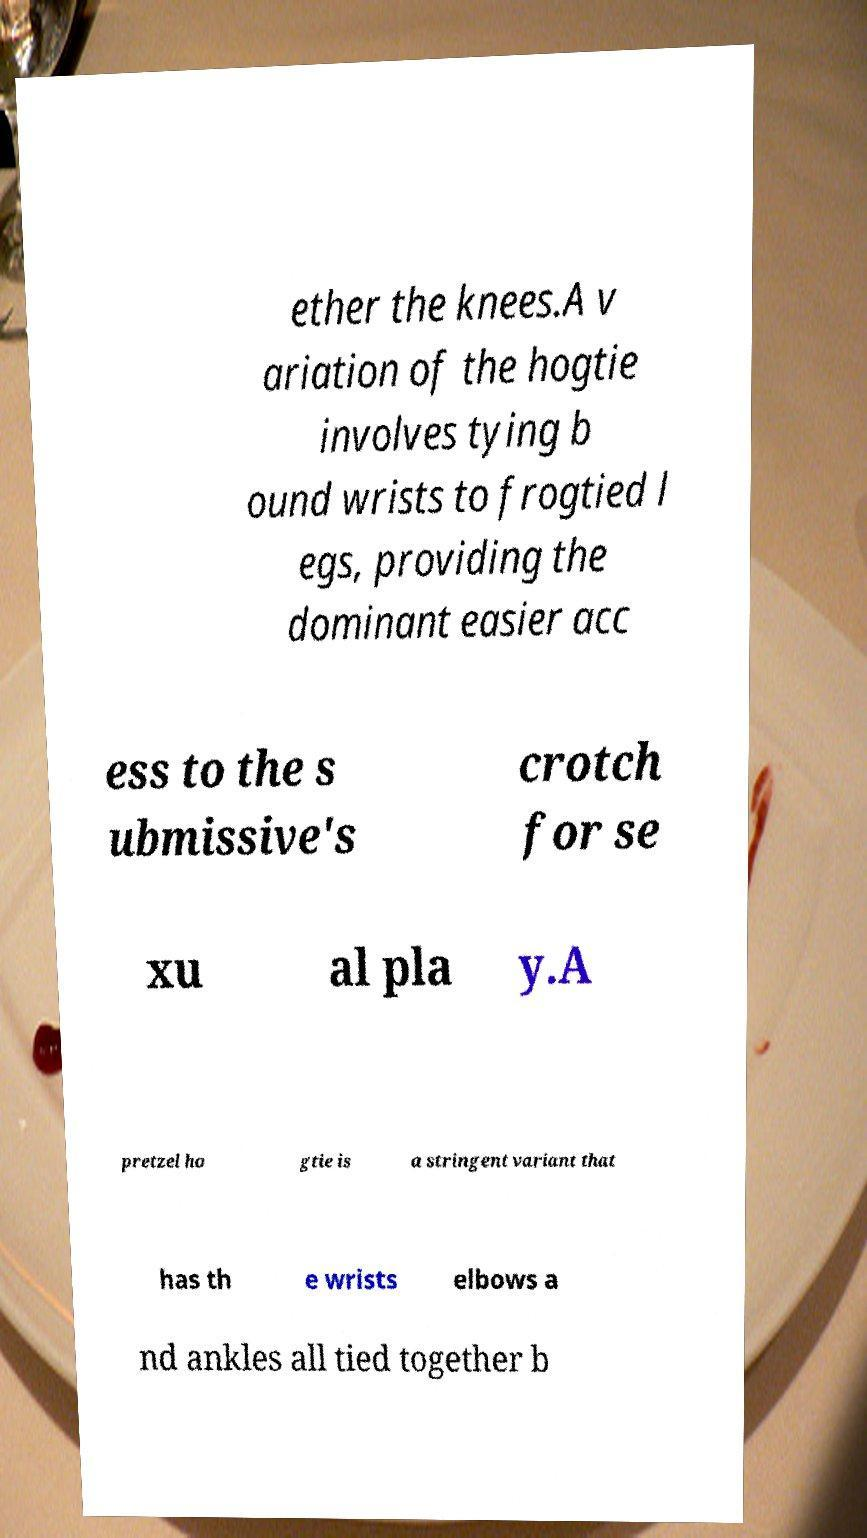There's text embedded in this image that I need extracted. Can you transcribe it verbatim? ether the knees.A v ariation of the hogtie involves tying b ound wrists to frogtied l egs, providing the dominant easier acc ess to the s ubmissive's crotch for se xu al pla y.A pretzel ho gtie is a stringent variant that has th e wrists elbows a nd ankles all tied together b 